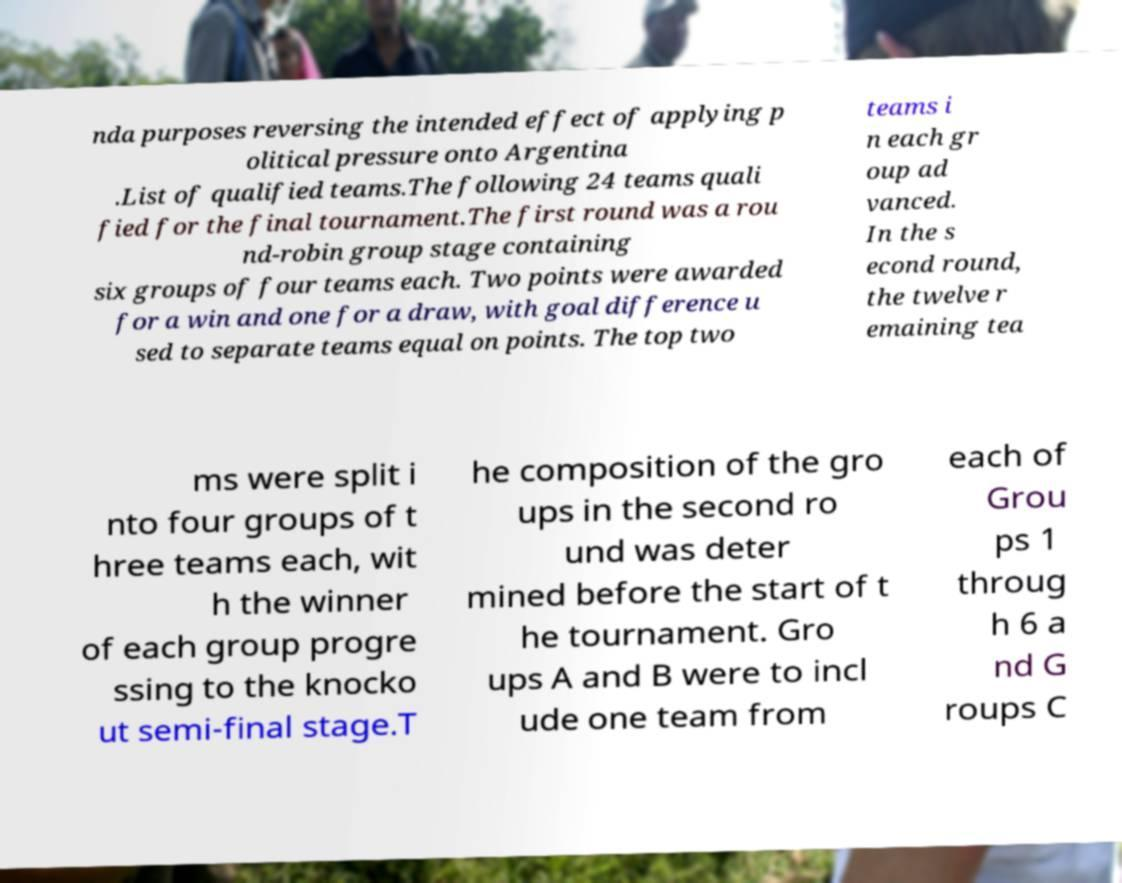Could you extract and type out the text from this image? nda purposes reversing the intended effect of applying p olitical pressure onto Argentina .List of qualified teams.The following 24 teams quali fied for the final tournament.The first round was a rou nd-robin group stage containing six groups of four teams each. Two points were awarded for a win and one for a draw, with goal difference u sed to separate teams equal on points. The top two teams i n each gr oup ad vanced. In the s econd round, the twelve r emaining tea ms were split i nto four groups of t hree teams each, wit h the winner of each group progre ssing to the knocko ut semi-final stage.T he composition of the gro ups in the second ro und was deter mined before the start of t he tournament. Gro ups A and B were to incl ude one team from each of Grou ps 1 throug h 6 a nd G roups C 